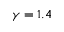Convert formula to latex. <formula><loc_0><loc_0><loc_500><loc_500>\gamma = 1 . 4</formula> 